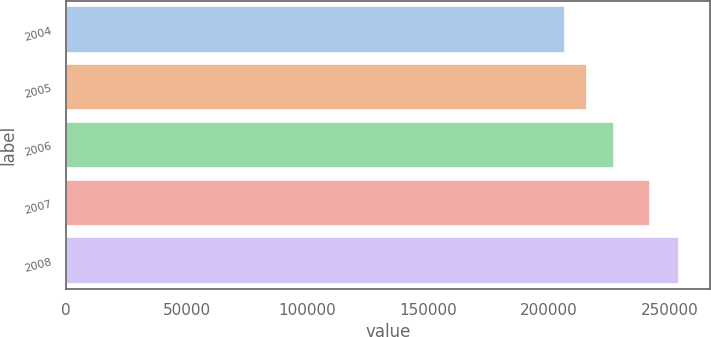Convert chart. <chart><loc_0><loc_0><loc_500><loc_500><bar_chart><fcel>2004<fcel>2005<fcel>2006<fcel>2007<fcel>2008<nl><fcel>207000<fcel>216000<fcel>227000<fcel>242000<fcel>254000<nl></chart> 